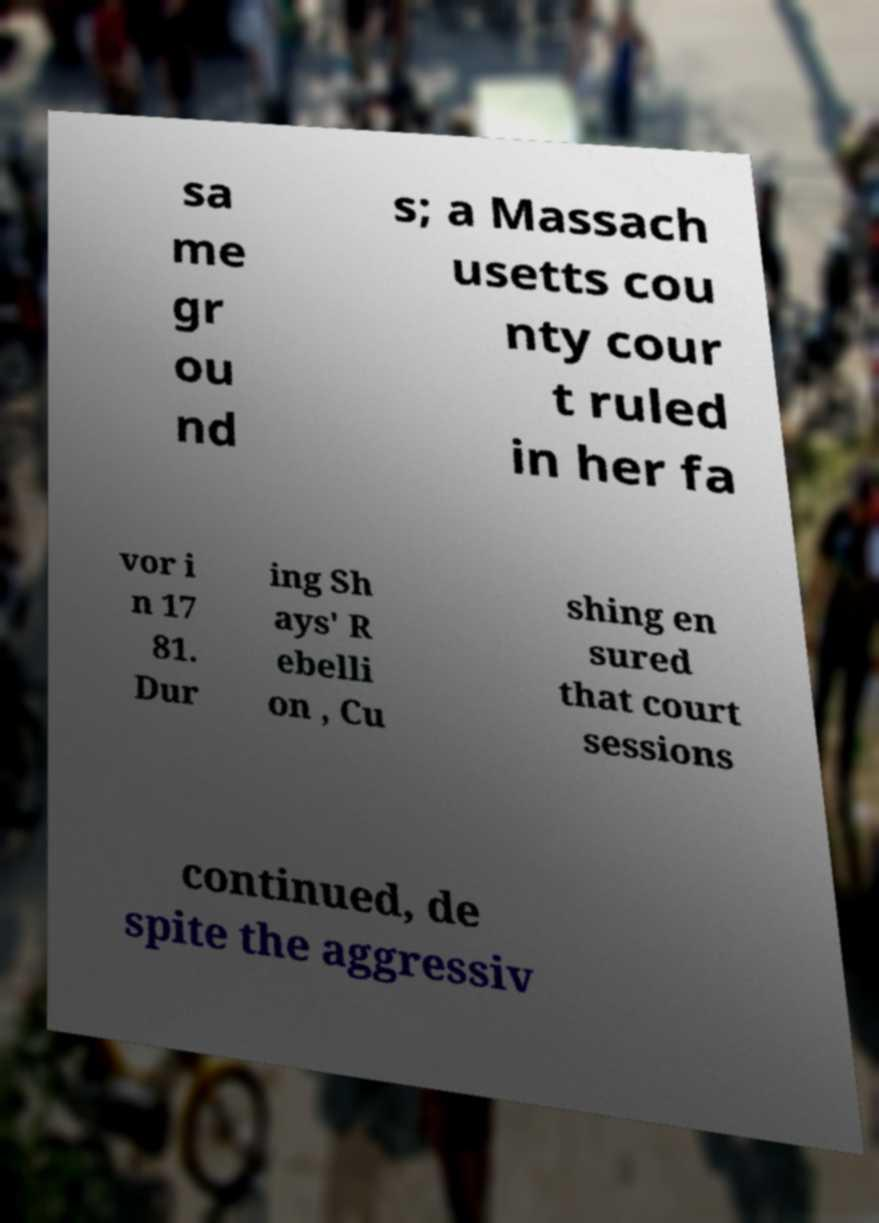I need the written content from this picture converted into text. Can you do that? sa me gr ou nd s; a Massach usetts cou nty cour t ruled in her fa vor i n 17 81. Dur ing Sh ays' R ebelli on , Cu shing en sured that court sessions continued, de spite the aggressiv 